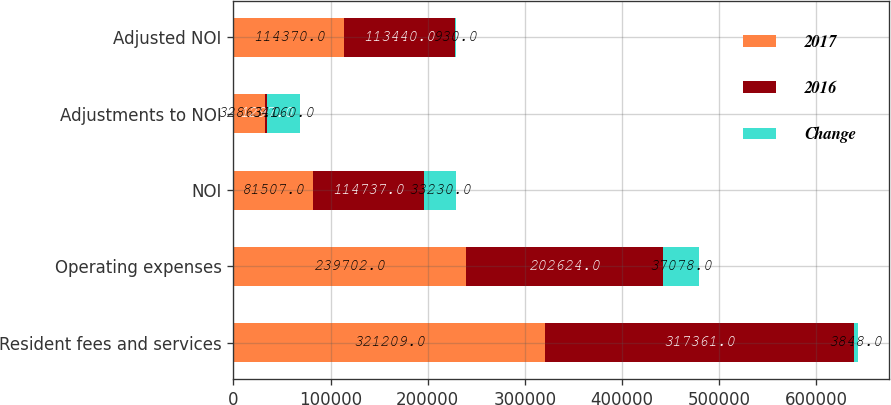Convert chart. <chart><loc_0><loc_0><loc_500><loc_500><stacked_bar_chart><ecel><fcel>Resident fees and services<fcel>Operating expenses<fcel>NOI<fcel>Adjustments to NOI<fcel>Adjusted NOI<nl><fcel>2017<fcel>321209<fcel>239702<fcel>81507<fcel>32863<fcel>114370<nl><fcel>2016<fcel>317361<fcel>202624<fcel>114737<fcel>1297<fcel>113440<nl><fcel>Change<fcel>3848<fcel>37078<fcel>33230<fcel>34160<fcel>930<nl></chart> 